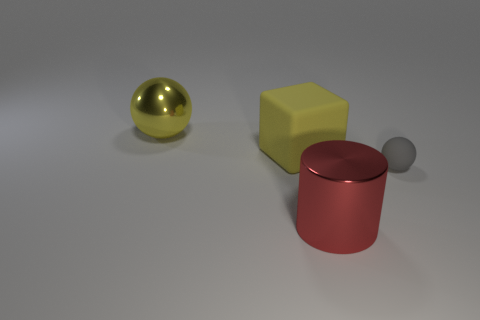Add 3 big brown blocks. How many objects exist? 7 Subtract all red balls. Subtract all yellow cylinders. How many balls are left? 2 Subtract all cubes. How many objects are left? 3 Subtract all small cyan rubber cubes. Subtract all big red objects. How many objects are left? 3 Add 1 tiny gray rubber objects. How many tiny gray rubber objects are left? 2 Add 4 small rubber balls. How many small rubber balls exist? 5 Subtract 0 blue cylinders. How many objects are left? 4 